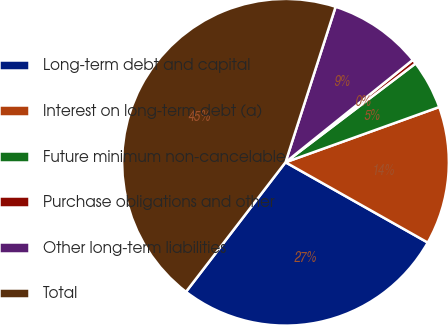Convert chart. <chart><loc_0><loc_0><loc_500><loc_500><pie_chart><fcel>Long-term debt and capital<fcel>Interest on long-term debt (a)<fcel>Future minimum non-cancelable<fcel>Purchase obligations and other<fcel>Other long-term liabilities<fcel>Total<nl><fcel>27.25%<fcel>13.67%<fcel>4.85%<fcel>0.44%<fcel>9.26%<fcel>44.54%<nl></chart> 